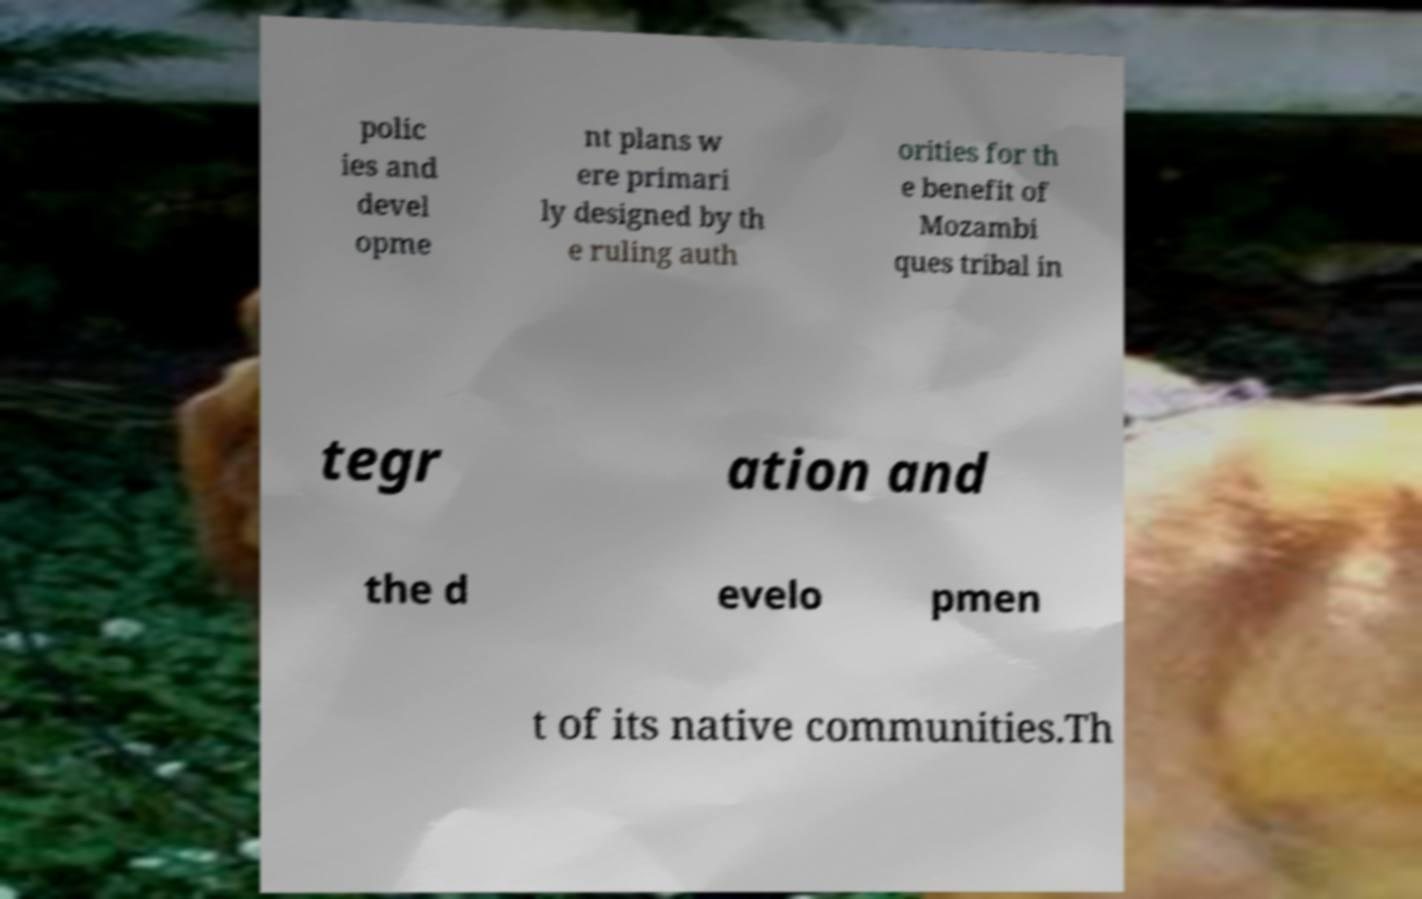Can you accurately transcribe the text from the provided image for me? polic ies and devel opme nt plans w ere primari ly designed by th e ruling auth orities for th e benefit of Mozambi ques tribal in tegr ation and the d evelo pmen t of its native communities.Th 